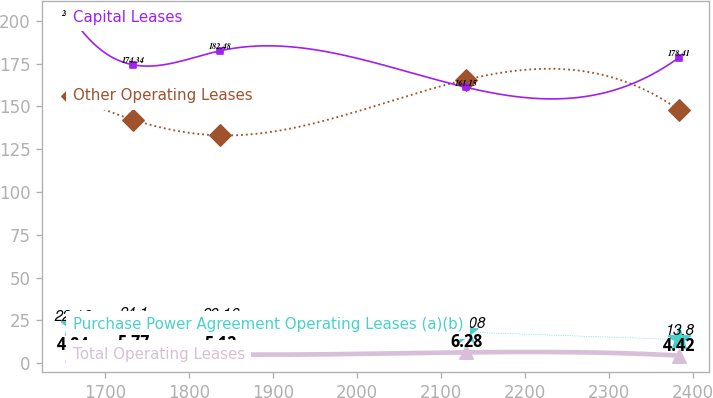Convert chart to OTSL. <chart><loc_0><loc_0><loc_500><loc_500><line_chart><ecel><fcel>Purchase Power Agreement Operating Leases (a)(b)<fcel>Other Operating Leases<fcel>Capital Leases<fcel>Total Operating Leases<nl><fcel>1660.53<fcel>22.16<fcel>156.12<fcel>201.85<fcel>4.84<nl><fcel>1732.82<fcel>24.1<fcel>142.21<fcel>174.34<fcel>5.77<nl><fcel>1836.32<fcel>23.16<fcel>133.09<fcel>182.48<fcel>5.12<nl><fcel>2130.15<fcel>18.08<fcel>165.64<fcel>161.15<fcel>6.28<nl><fcel>2383.39<fcel>13.8<fcel>148.17<fcel>178.41<fcel>4.42<nl></chart> 